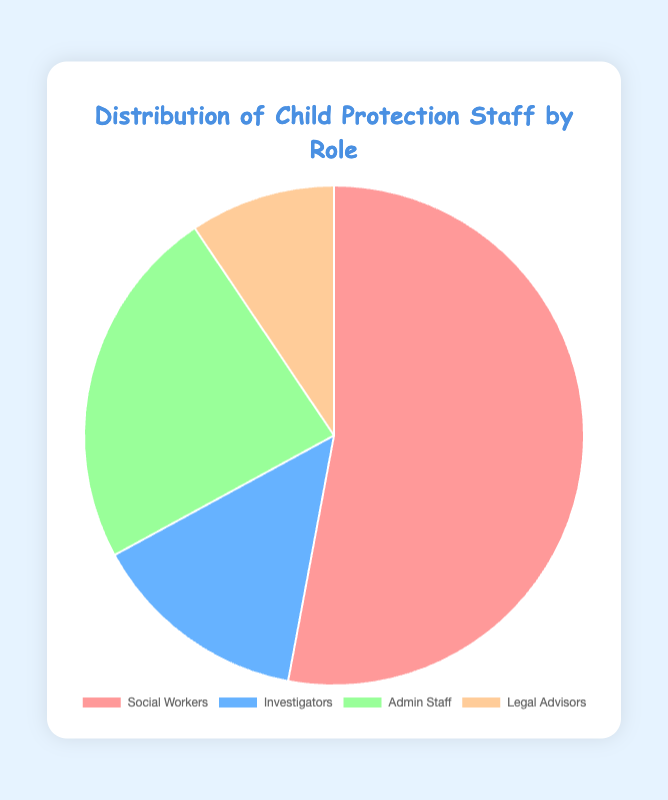What's the largest staff group in Child Protection? By examining the pie chart, it's clear that the Social Workers segment is the largest portion of the chart in red color. So, the Social Workers group has the highest count.
Answer: Social Workers Which role has the smallest representation in the staff distribution? When looking at the pie chart, the smallest segment represented by the yellow color corresponds to Legal Advisors.
Answer: Legal Advisors What is the combined total number of Social Workers and Admin Staff? The count of Social Workers is 450, and the count of Admin Staff is 200. Adding these two together gives 450 + 200 = 650.
Answer: 650 How does the number of Investigators compare to the number of Legal Advisors? Investigators are represented by the blue segment and have a count of 120, while Legal Advisors, represented by the yellow segment, have a count of 80. Thus, there are more Investigators than Legal Advisors.
Answer: More Investigators What percentage of the total staff are Admin Staff? Admin Staff have a count of 200. The total number of staff is 450 (Social Workers) + 120 (Investigators) + 200 (Admin Staff) + 80 (Legal Advisors) = 850. The percentage is (200 / 850) * 100 ≈ 23.5%.
Answer: 23.5% What two roles combined account for more than 60% of the staff? Social Workers (450) and Admin Staff (200) together account for a combined 450 + 200 = 650. The total is 850, and the percentage is (650 / 850) * 100 ≈ 76.5%. Only these two roles together exceed 60%.
Answer: Social Workers and Admin Staff Which color in the pie chart represents Social Workers, and how does one know? Social Workers are represented by the largest segment in red color, as seen in the visual distribution of sections.
Answer: Red If half of the Admin Staff were reassigned to the Investigators' role, what would be the new count for Investigators? There are currently 200 Admin Staff. Half of them is 200 / 2 = 100. Adding these to the current number of Investigators (120) would result in 120 + 100 = 220 Investigators.
Answer: 220 What is the ratio of Social Workers to Legal Advisors? The count of Social Workers is 450, and the count of Legal Advisors is 80. The ratio is 450:80, which simplifies to 45:8.
Answer: 45:8 